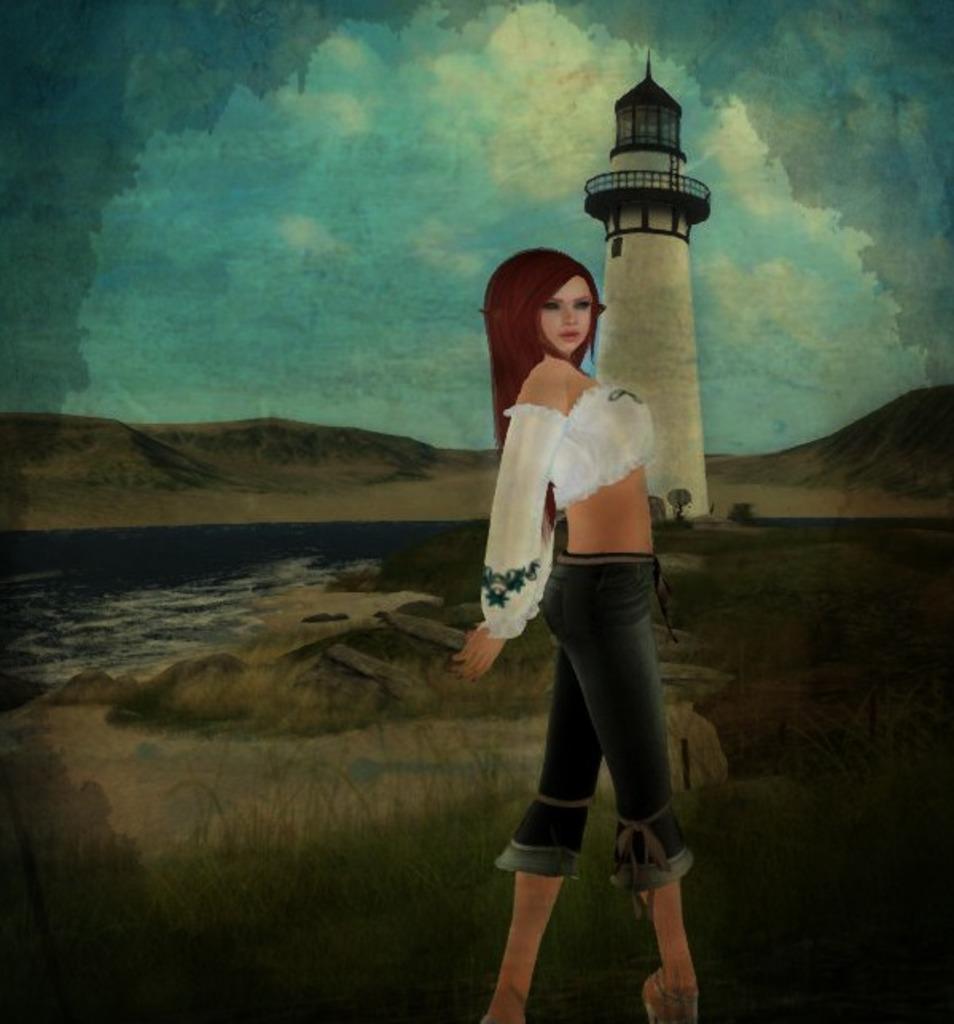Please provide a concise description of this image. This image is a painting. In this image there is a lady standing. In the background there is a tower and we can see hills and sky. At the bottom there is grass and we can see a river. 